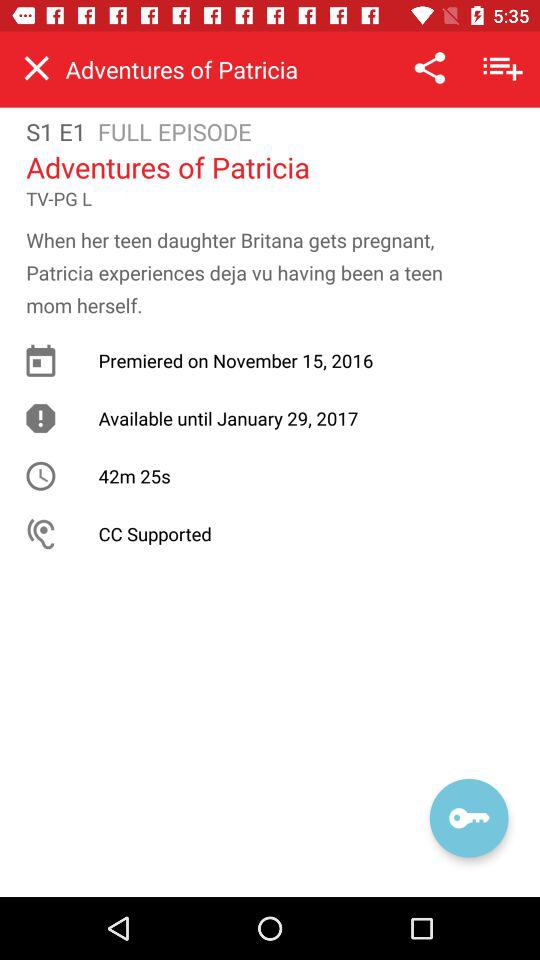What is the duration of the series? The duration of the series is 42 minutes 25 seconds. 